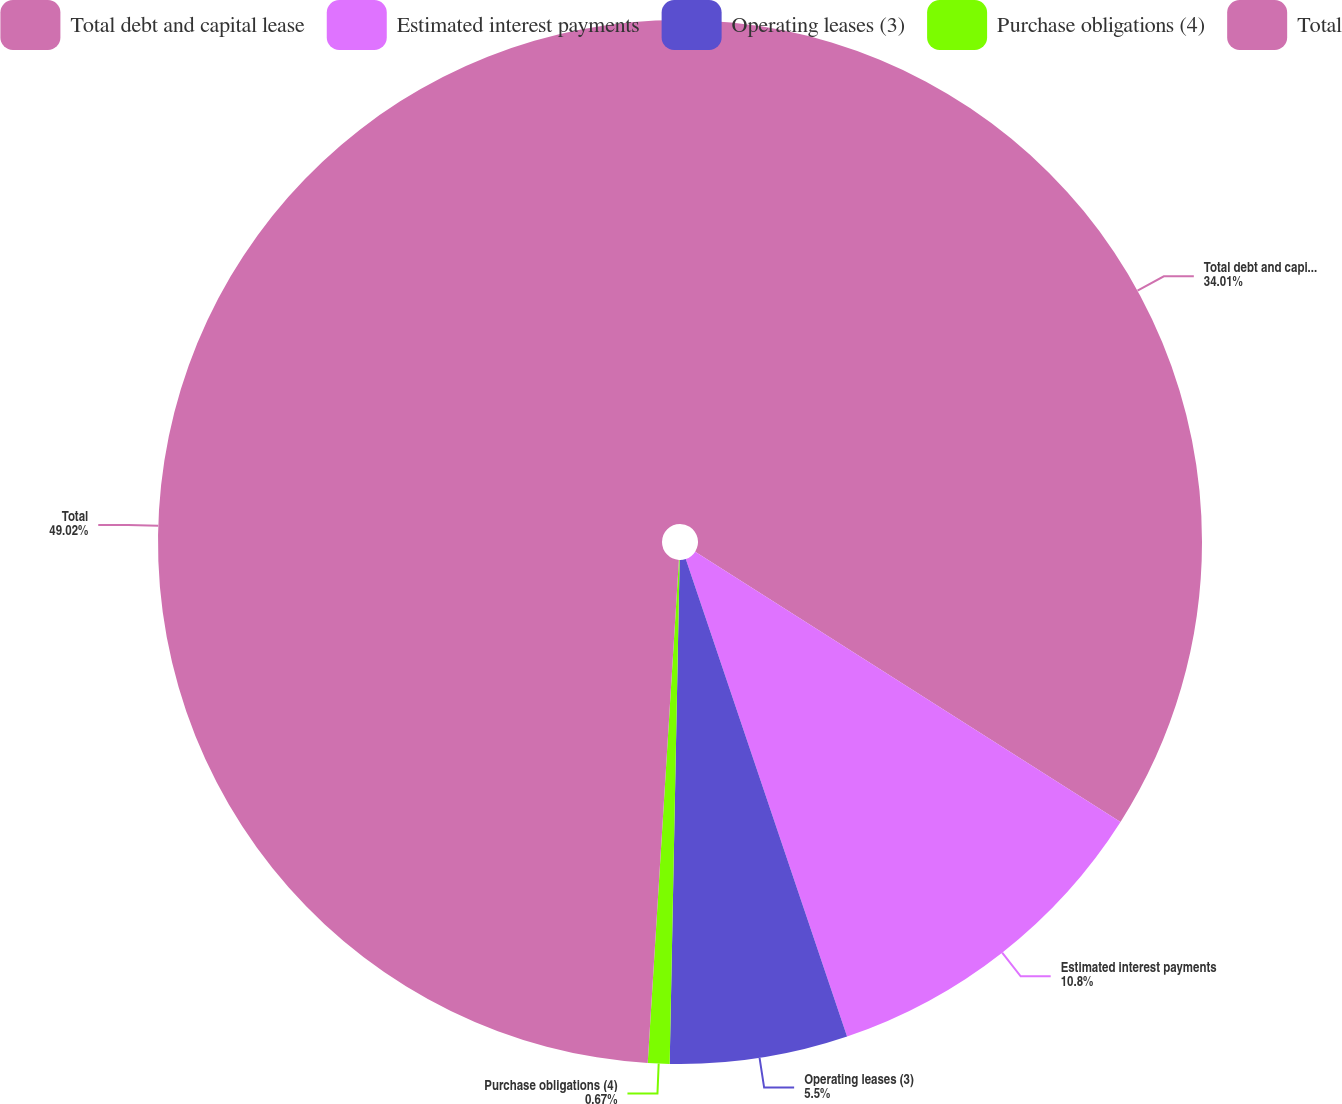<chart> <loc_0><loc_0><loc_500><loc_500><pie_chart><fcel>Total debt and capital lease<fcel>Estimated interest payments<fcel>Operating leases (3)<fcel>Purchase obligations (4)<fcel>Total<nl><fcel>34.01%<fcel>10.8%<fcel>5.5%<fcel>0.67%<fcel>49.01%<nl></chart> 